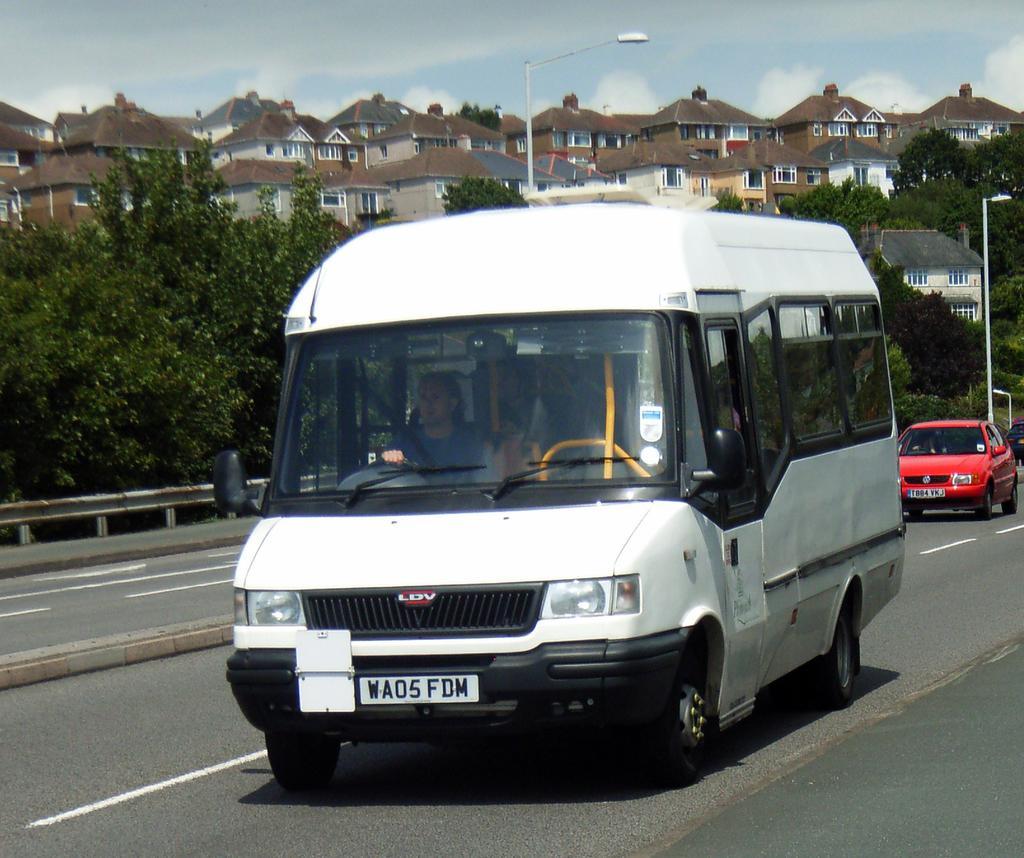Could you give a brief overview of what you see in this image? In the image we can see there are vehicles parked on the road and there is a person sitting on the driver seat. Behind there are trees and buildings. There are street light poles on the road and there is a cloudy sky. 